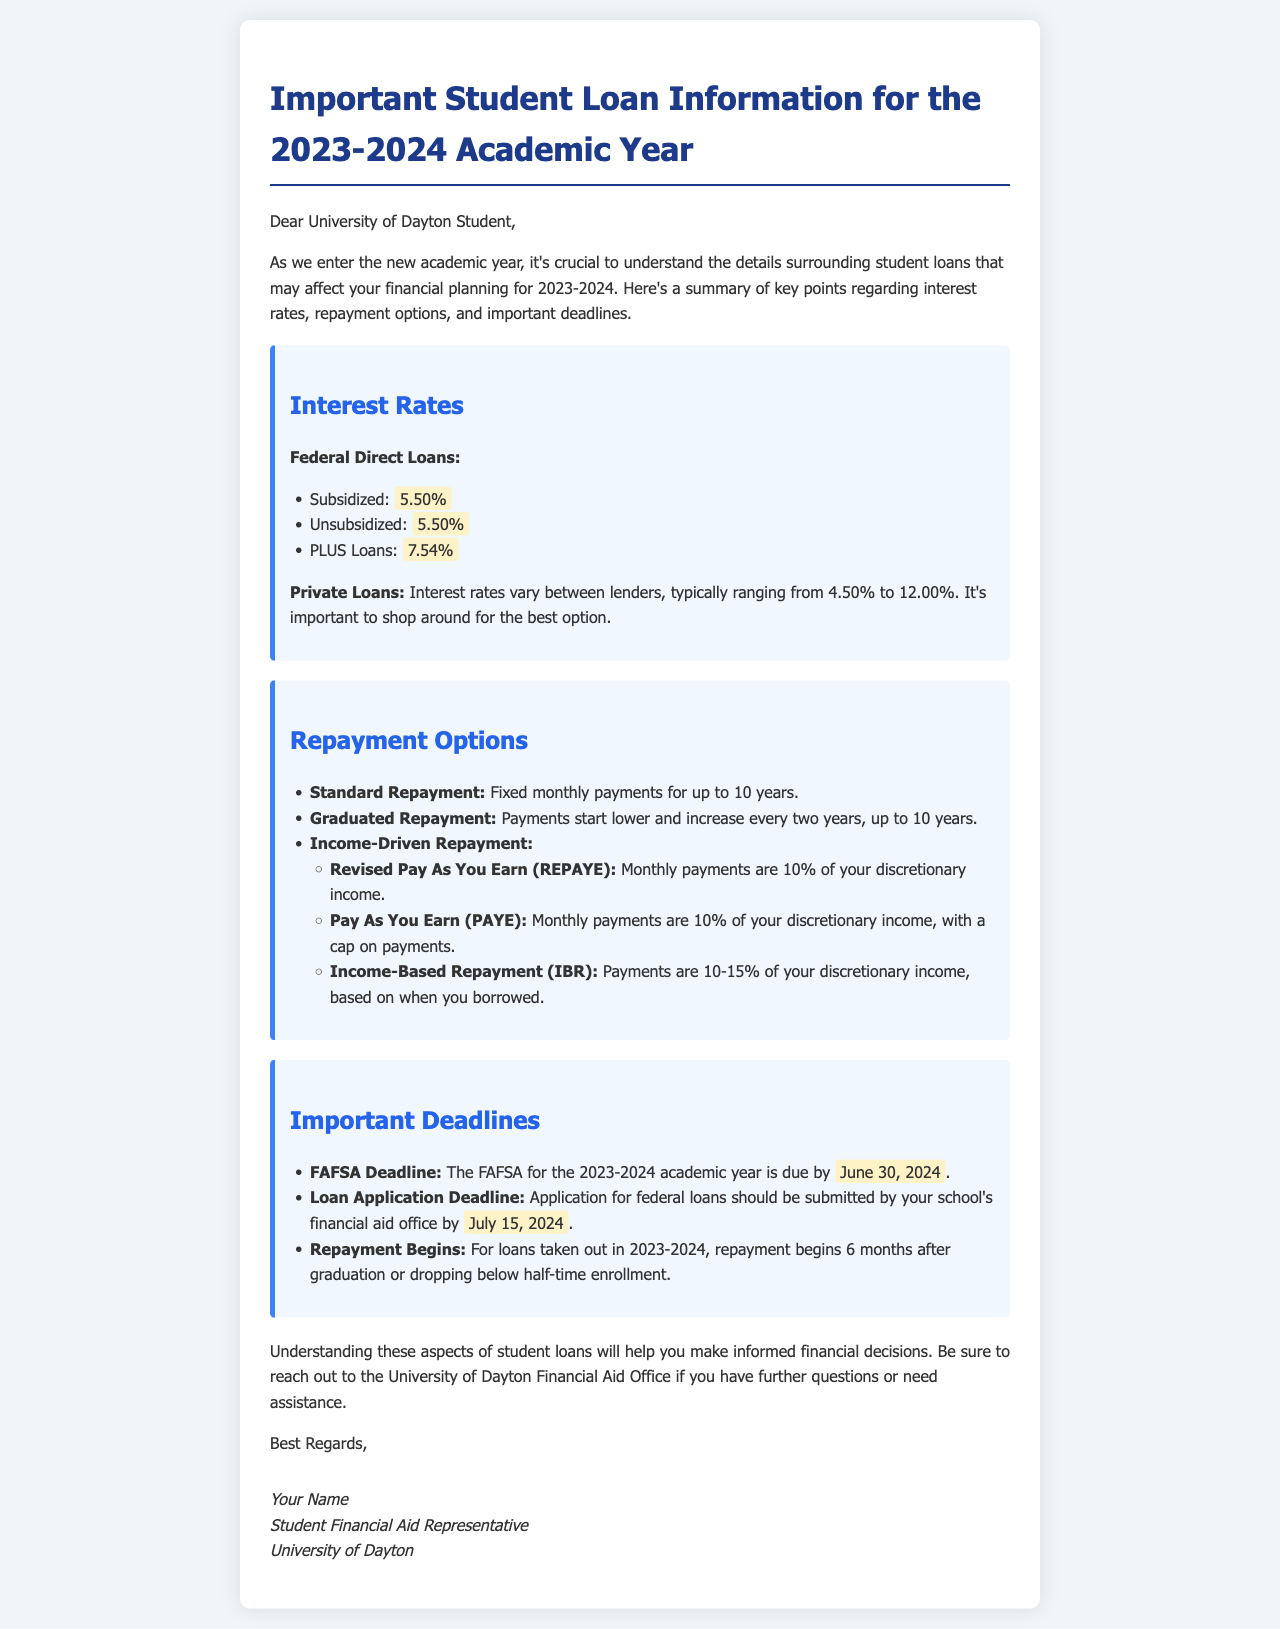What is the interest rate for Subsidized Federal Direct Loans? The document states that the interest rate for Subsidized Federal Direct Loans is 5.50%.
Answer: 5.50% What is the deadline for submitting the FAFSA for the 2023-2024 academic year? According to the document, the FAFSA deadline is June 30, 2024.
Answer: June 30, 2024 What type of repayment option starts with lower payments that increase every two years? The document mentions the Graduated Repayment option starts lower and increases every two years.
Answer: Graduated Repayment What is the interest rate range for Private Loans? The document indicates that interest rates for Private Loans typically range from 4.50% to 12.00%.
Answer: 4.50% to 12.00% When do repayments begin for loans taken out in 2023-2024? The document specifies that repayments for those loans begin 6 months after graduation or dropping below half-time enrollment.
Answer: 6 months after graduation or dropping below half-time enrollment What are the two repayment options that involve 10% of discretionary income? The document lists Revised Pay As You Earn (REPAYE) and Pay As You Earn (PAYE) as both requiring 10% of discretionary income.
Answer: REPAYE and PAYE What should students do if they have further questions regarding student loans? The document advises students to reach out to the University of Dayton Financial Aid Office for further questions.
Answer: University of Dayton Financial Aid Office 